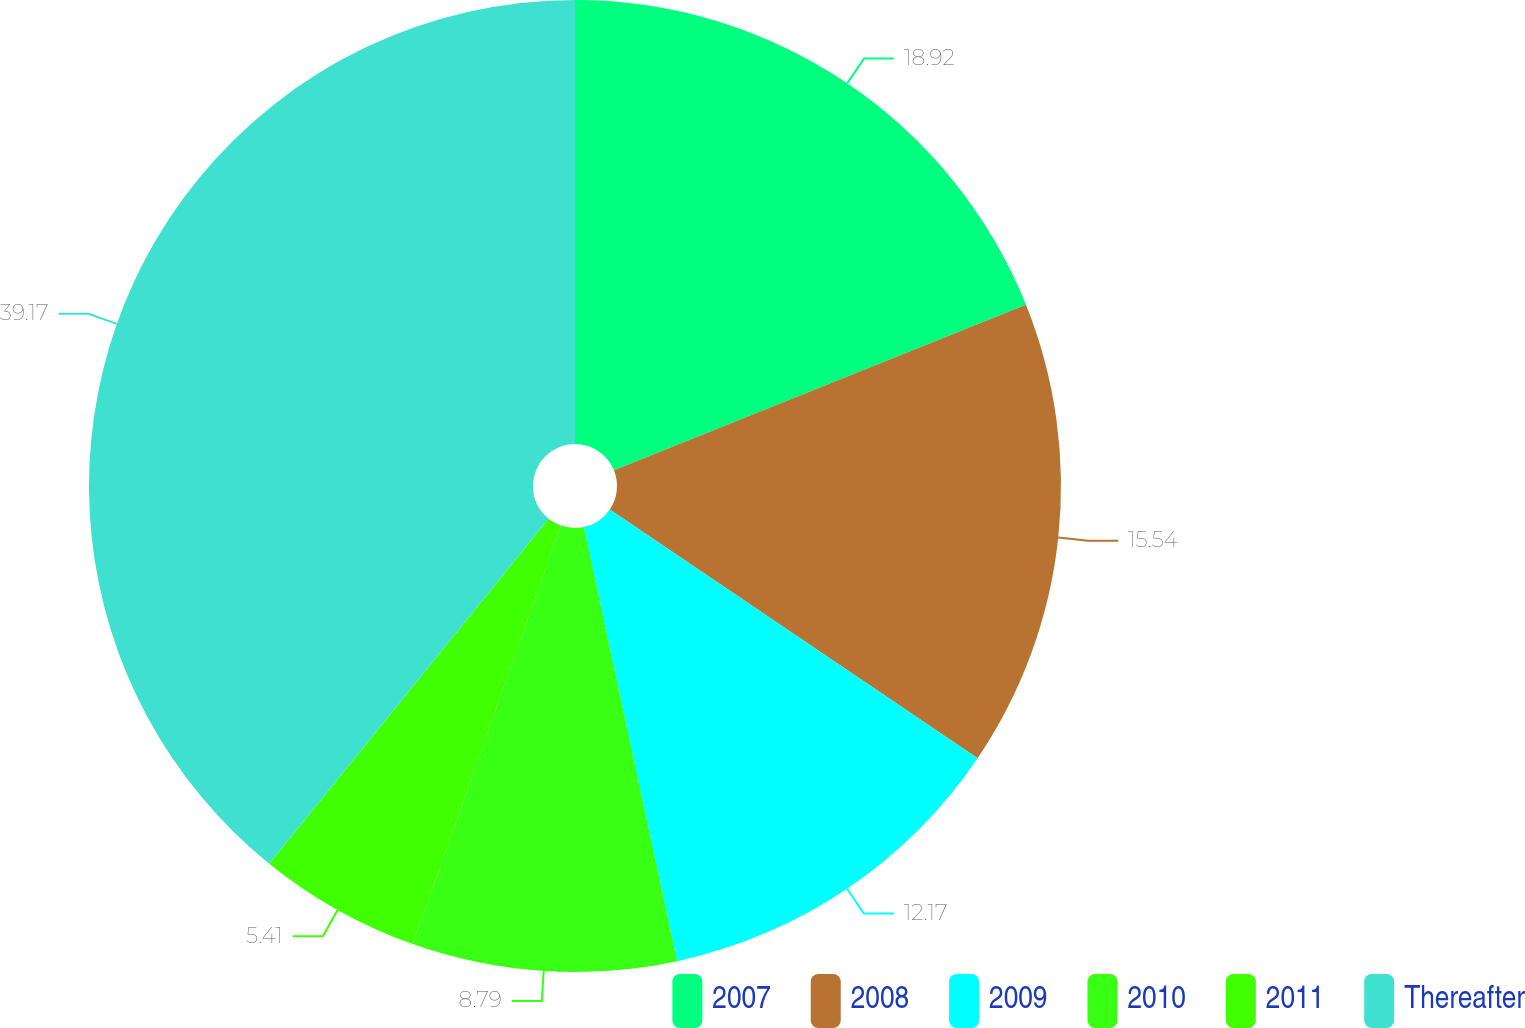<chart> <loc_0><loc_0><loc_500><loc_500><pie_chart><fcel>2007<fcel>2008<fcel>2009<fcel>2010<fcel>2011<fcel>Thereafter<nl><fcel>18.92%<fcel>15.54%<fcel>12.17%<fcel>8.79%<fcel>5.41%<fcel>39.17%<nl></chart> 